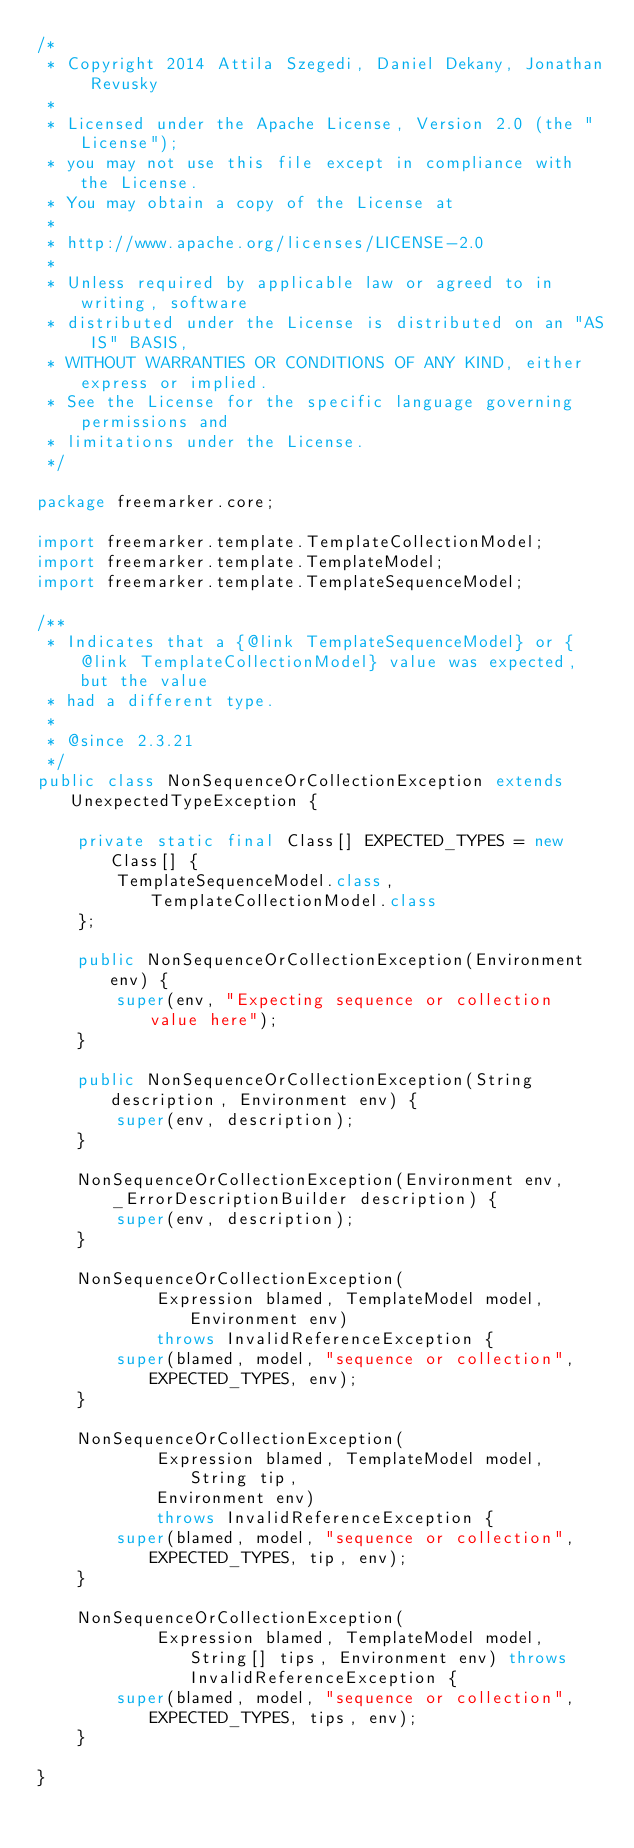<code> <loc_0><loc_0><loc_500><loc_500><_Java_>/*
 * Copyright 2014 Attila Szegedi, Daniel Dekany, Jonathan Revusky
 * 
 * Licensed under the Apache License, Version 2.0 (the "License");
 * you may not use this file except in compliance with the License.
 * You may obtain a copy of the License at
 * 
 * http://www.apache.org/licenses/LICENSE-2.0
 * 
 * Unless required by applicable law or agreed to in writing, software
 * distributed under the License is distributed on an "AS IS" BASIS,
 * WITHOUT WARRANTIES OR CONDITIONS OF ANY KIND, either express or implied.
 * See the License for the specific language governing permissions and
 * limitations under the License.
 */

package freemarker.core;

import freemarker.template.TemplateCollectionModel;
import freemarker.template.TemplateModel;
import freemarker.template.TemplateSequenceModel;

/**
 * Indicates that a {@link TemplateSequenceModel} or {@link TemplateCollectionModel} value was expected, but the value
 * had a different type.
 * 
 * @since 2.3.21
 */
public class NonSequenceOrCollectionException extends UnexpectedTypeException {

    private static final Class[] EXPECTED_TYPES = new Class[] {
        TemplateSequenceModel.class, TemplateCollectionModel.class
    };
    
    public NonSequenceOrCollectionException(Environment env) {
        super(env, "Expecting sequence or collection value here");
    }

    public NonSequenceOrCollectionException(String description, Environment env) {
        super(env, description);
    }

    NonSequenceOrCollectionException(Environment env, _ErrorDescriptionBuilder description) {
        super(env, description);
    }

    NonSequenceOrCollectionException(
            Expression blamed, TemplateModel model, Environment env)
            throws InvalidReferenceException {
        super(blamed, model, "sequence or collection", EXPECTED_TYPES, env);
    }

    NonSequenceOrCollectionException(
            Expression blamed, TemplateModel model, String tip,
            Environment env)
            throws InvalidReferenceException {
        super(blamed, model, "sequence or collection", EXPECTED_TYPES, tip, env);
    }

    NonSequenceOrCollectionException(
            Expression blamed, TemplateModel model, String[] tips, Environment env) throws InvalidReferenceException {
        super(blamed, model, "sequence or collection", EXPECTED_TYPES, tips, env);
    }    

}
</code> 